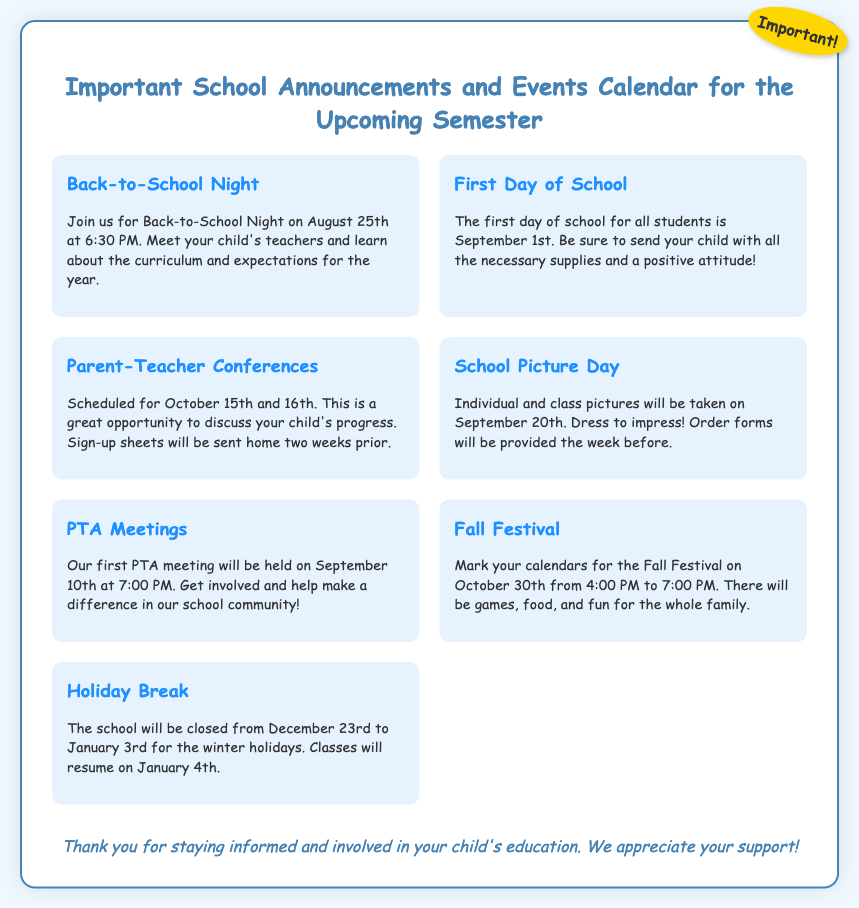What date is Back-to-School Night? The exact date for Back-to-School Night is mentioned in the document as August 25th.
Answer: August 25th When does the school close for the winter holidays? The document specifies the closure dates for the school during the winter holidays as December 23rd to January 3rd.
Answer: December 23rd to January 3rd What time is the PTA meeting on September 10th? The document indicates that the PTA meeting will start at 7:00 PM on September 10th.
Answer: 7:00 PM How many days are there between the First Day of School and School Picture Day? From the First Day of School on September 1st to School Picture Day on September 20th, there are 19 days in between.
Answer: 19 days What event occurs on October 30th? The Fall Festival is mentioned in the document, which is scheduled for October 30th from 4:00 PM to 7:00 PM.
Answer: Fall Festival 